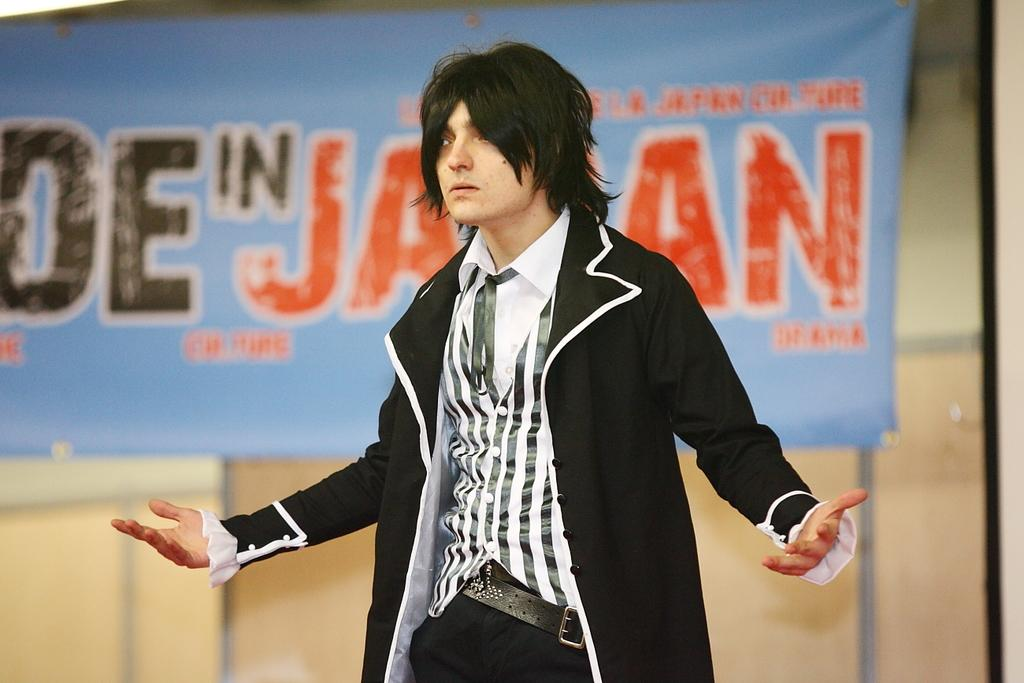What is the main subject of the image? There is a man standing in the image. Where is the man located in the image? The man is in the middle of the image. What can be seen behind the man? There is a banner behind the man. What type of branch is the lawyer holding in the image? There is no lawyer or branch present in the image; it features a man standing in the middle with a banner behind him. 